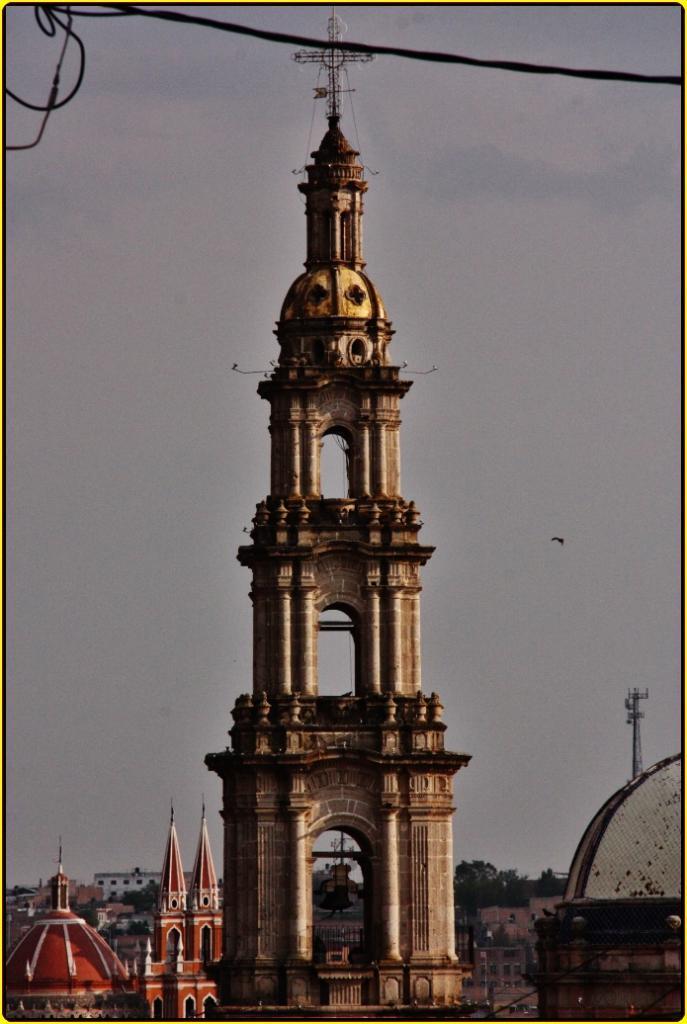How would you summarize this image in a sentence or two? In this picture in the front there is a tower and on the top there is a wire. In the background there are buildings and the sky is cloudy. 